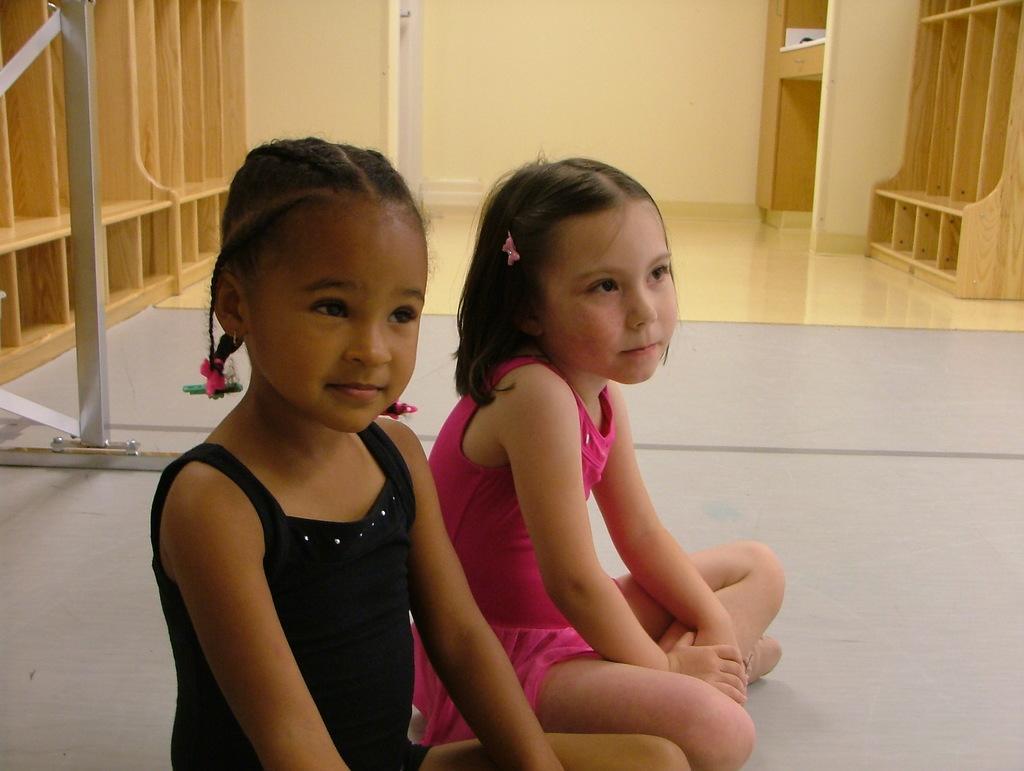Describe this image in one or two sentences. There are two girls sitting on the floor and we can see rods. We can see wooden racks and wall. 